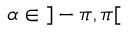Convert formula to latex. <formula><loc_0><loc_0><loc_500><loc_500>\alpha \in \, ] - \pi , \pi [</formula> 